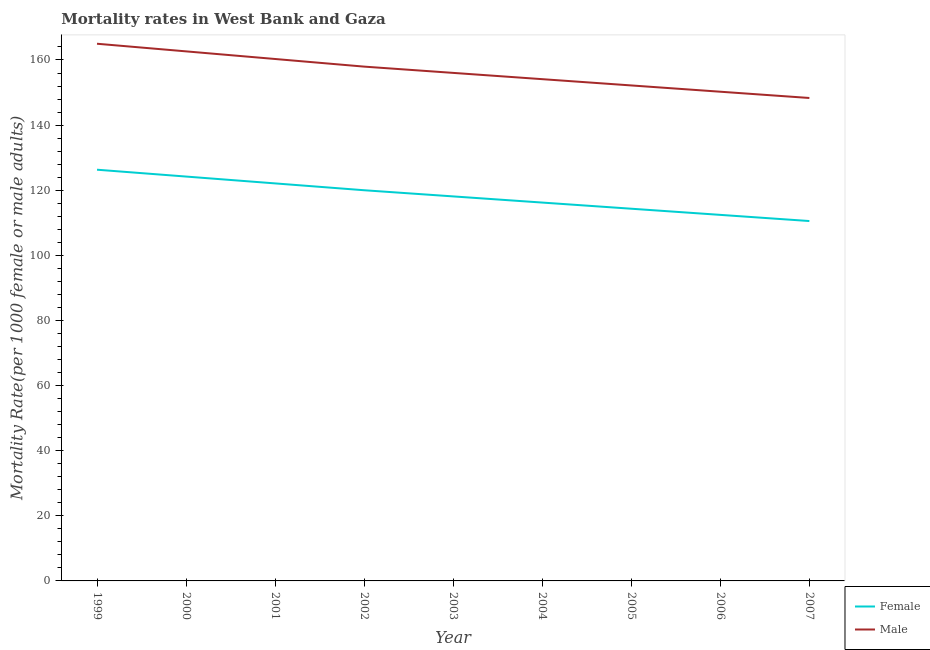Does the line corresponding to female mortality rate intersect with the line corresponding to male mortality rate?
Your response must be concise. No. What is the male mortality rate in 2000?
Your response must be concise. 162.65. Across all years, what is the maximum male mortality rate?
Your answer should be compact. 164.99. Across all years, what is the minimum male mortality rate?
Keep it short and to the point. 148.33. In which year was the male mortality rate maximum?
Offer a terse response. 1999. In which year was the male mortality rate minimum?
Offer a terse response. 2007. What is the total female mortality rate in the graph?
Ensure brevity in your answer.  1064.17. What is the difference between the male mortality rate in 2001 and that in 2005?
Ensure brevity in your answer.  8.12. What is the difference between the male mortality rate in 2004 and the female mortality rate in 2002?
Provide a succinct answer. 34.12. What is the average female mortality rate per year?
Make the answer very short. 118.24. In the year 2003, what is the difference between the female mortality rate and male mortality rate?
Your response must be concise. -37.94. In how many years, is the female mortality rate greater than 36?
Your answer should be very brief. 9. What is the ratio of the male mortality rate in 2000 to that in 2001?
Keep it short and to the point. 1.01. Is the female mortality rate in 2003 less than that in 2006?
Provide a short and direct response. No. What is the difference between the highest and the second highest male mortality rate?
Keep it short and to the point. 2.34. What is the difference between the highest and the lowest female mortality rate?
Offer a terse response. 15.76. In how many years, is the male mortality rate greater than the average male mortality rate taken over all years?
Provide a short and direct response. 4. Is the female mortality rate strictly less than the male mortality rate over the years?
Keep it short and to the point. Yes. How many lines are there?
Your response must be concise. 2. What is the difference between two consecutive major ticks on the Y-axis?
Make the answer very short. 20. Does the graph contain any zero values?
Make the answer very short. No. How are the legend labels stacked?
Your answer should be compact. Vertical. What is the title of the graph?
Give a very brief answer. Mortality rates in West Bank and Gaza. What is the label or title of the Y-axis?
Give a very brief answer. Mortality Rate(per 1000 female or male adults). What is the Mortality Rate(per 1000 female or male adults) in Female in 1999?
Provide a short and direct response. 126.3. What is the Mortality Rate(per 1000 female or male adults) of Male in 1999?
Your answer should be very brief. 164.99. What is the Mortality Rate(per 1000 female or male adults) in Female in 2000?
Give a very brief answer. 124.2. What is the Mortality Rate(per 1000 female or male adults) in Male in 2000?
Your response must be concise. 162.65. What is the Mortality Rate(per 1000 female or male adults) of Female in 2001?
Make the answer very short. 122.09. What is the Mortality Rate(per 1000 female or male adults) in Male in 2001?
Provide a short and direct response. 160.31. What is the Mortality Rate(per 1000 female or male adults) in Female in 2002?
Give a very brief answer. 119.99. What is the Mortality Rate(per 1000 female or male adults) of Male in 2002?
Your response must be concise. 157.96. What is the Mortality Rate(per 1000 female or male adults) in Female in 2003?
Your answer should be very brief. 118.1. What is the Mortality Rate(per 1000 female or male adults) of Male in 2003?
Your answer should be very brief. 156.04. What is the Mortality Rate(per 1000 female or male adults) in Female in 2004?
Ensure brevity in your answer.  116.21. What is the Mortality Rate(per 1000 female or male adults) in Male in 2004?
Offer a very short reply. 154.11. What is the Mortality Rate(per 1000 female or male adults) of Female in 2005?
Provide a short and direct response. 114.32. What is the Mortality Rate(per 1000 female or male adults) of Male in 2005?
Make the answer very short. 152.18. What is the Mortality Rate(per 1000 female or male adults) in Female in 2006?
Your response must be concise. 112.43. What is the Mortality Rate(per 1000 female or male adults) in Male in 2006?
Your response must be concise. 150.25. What is the Mortality Rate(per 1000 female or male adults) in Female in 2007?
Keep it short and to the point. 110.53. What is the Mortality Rate(per 1000 female or male adults) in Male in 2007?
Provide a short and direct response. 148.33. Across all years, what is the maximum Mortality Rate(per 1000 female or male adults) in Female?
Offer a very short reply. 126.3. Across all years, what is the maximum Mortality Rate(per 1000 female or male adults) of Male?
Ensure brevity in your answer.  164.99. Across all years, what is the minimum Mortality Rate(per 1000 female or male adults) of Female?
Offer a very short reply. 110.53. Across all years, what is the minimum Mortality Rate(per 1000 female or male adults) of Male?
Provide a short and direct response. 148.33. What is the total Mortality Rate(per 1000 female or male adults) of Female in the graph?
Offer a very short reply. 1064.17. What is the total Mortality Rate(per 1000 female or male adults) in Male in the graph?
Ensure brevity in your answer.  1406.81. What is the difference between the Mortality Rate(per 1000 female or male adults) in Female in 1999 and that in 2000?
Ensure brevity in your answer.  2.1. What is the difference between the Mortality Rate(per 1000 female or male adults) of Male in 1999 and that in 2000?
Give a very brief answer. 2.34. What is the difference between the Mortality Rate(per 1000 female or male adults) in Female in 1999 and that in 2001?
Give a very brief answer. 4.2. What is the difference between the Mortality Rate(per 1000 female or male adults) in Male in 1999 and that in 2001?
Make the answer very short. 4.68. What is the difference between the Mortality Rate(per 1000 female or male adults) in Female in 1999 and that in 2002?
Provide a short and direct response. 6.31. What is the difference between the Mortality Rate(per 1000 female or male adults) in Male in 1999 and that in 2002?
Offer a terse response. 7.03. What is the difference between the Mortality Rate(per 1000 female or male adults) in Female in 1999 and that in 2003?
Offer a very short reply. 8.2. What is the difference between the Mortality Rate(per 1000 female or male adults) in Male in 1999 and that in 2003?
Keep it short and to the point. 8.95. What is the difference between the Mortality Rate(per 1000 female or male adults) of Female in 1999 and that in 2004?
Give a very brief answer. 10.09. What is the difference between the Mortality Rate(per 1000 female or male adults) in Male in 1999 and that in 2004?
Give a very brief answer. 10.88. What is the difference between the Mortality Rate(per 1000 female or male adults) in Female in 1999 and that in 2005?
Offer a terse response. 11.98. What is the difference between the Mortality Rate(per 1000 female or male adults) of Male in 1999 and that in 2005?
Your answer should be very brief. 12.81. What is the difference between the Mortality Rate(per 1000 female or male adults) in Female in 1999 and that in 2006?
Ensure brevity in your answer.  13.87. What is the difference between the Mortality Rate(per 1000 female or male adults) in Male in 1999 and that in 2006?
Make the answer very short. 14.73. What is the difference between the Mortality Rate(per 1000 female or male adults) in Female in 1999 and that in 2007?
Provide a short and direct response. 15.76. What is the difference between the Mortality Rate(per 1000 female or male adults) of Male in 1999 and that in 2007?
Your answer should be compact. 16.66. What is the difference between the Mortality Rate(per 1000 female or male adults) in Female in 2000 and that in 2001?
Your answer should be very brief. 2.1. What is the difference between the Mortality Rate(per 1000 female or male adults) of Male in 2000 and that in 2001?
Provide a short and direct response. 2.34. What is the difference between the Mortality Rate(per 1000 female or male adults) of Female in 2000 and that in 2002?
Give a very brief answer. 4.2. What is the difference between the Mortality Rate(per 1000 female or male adults) in Male in 2000 and that in 2002?
Offer a very short reply. 4.68. What is the difference between the Mortality Rate(per 1000 female or male adults) in Female in 2000 and that in 2003?
Your answer should be very brief. 6.1. What is the difference between the Mortality Rate(per 1000 female or male adults) of Male in 2000 and that in 2003?
Your answer should be very brief. 6.61. What is the difference between the Mortality Rate(per 1000 female or male adults) of Female in 2000 and that in 2004?
Offer a terse response. 7.99. What is the difference between the Mortality Rate(per 1000 female or male adults) of Male in 2000 and that in 2004?
Offer a terse response. 8.54. What is the difference between the Mortality Rate(per 1000 female or male adults) in Female in 2000 and that in 2005?
Your answer should be very brief. 9.88. What is the difference between the Mortality Rate(per 1000 female or male adults) of Male in 2000 and that in 2005?
Give a very brief answer. 10.47. What is the difference between the Mortality Rate(per 1000 female or male adults) in Female in 2000 and that in 2006?
Your response must be concise. 11.77. What is the difference between the Mortality Rate(per 1000 female or male adults) in Male in 2000 and that in 2006?
Give a very brief answer. 12.39. What is the difference between the Mortality Rate(per 1000 female or male adults) in Female in 2000 and that in 2007?
Provide a short and direct response. 13.66. What is the difference between the Mortality Rate(per 1000 female or male adults) of Male in 2000 and that in 2007?
Make the answer very short. 14.32. What is the difference between the Mortality Rate(per 1000 female or male adults) in Female in 2001 and that in 2002?
Your response must be concise. 2.1. What is the difference between the Mortality Rate(per 1000 female or male adults) of Male in 2001 and that in 2002?
Provide a short and direct response. 2.34. What is the difference between the Mortality Rate(per 1000 female or male adults) of Female in 2001 and that in 2003?
Your response must be concise. 3.99. What is the difference between the Mortality Rate(per 1000 female or male adults) in Male in 2001 and that in 2003?
Your response must be concise. 4.27. What is the difference between the Mortality Rate(per 1000 female or male adults) of Female in 2001 and that in 2004?
Make the answer very short. 5.89. What is the difference between the Mortality Rate(per 1000 female or male adults) of Male in 2001 and that in 2004?
Keep it short and to the point. 6.2. What is the difference between the Mortality Rate(per 1000 female or male adults) of Female in 2001 and that in 2005?
Offer a terse response. 7.78. What is the difference between the Mortality Rate(per 1000 female or male adults) of Male in 2001 and that in 2005?
Your response must be concise. 8.12. What is the difference between the Mortality Rate(per 1000 female or male adults) of Female in 2001 and that in 2006?
Provide a succinct answer. 9.67. What is the difference between the Mortality Rate(per 1000 female or male adults) of Male in 2001 and that in 2006?
Your answer should be compact. 10.05. What is the difference between the Mortality Rate(per 1000 female or male adults) of Female in 2001 and that in 2007?
Give a very brief answer. 11.56. What is the difference between the Mortality Rate(per 1000 female or male adults) in Male in 2001 and that in 2007?
Give a very brief answer. 11.98. What is the difference between the Mortality Rate(per 1000 female or male adults) in Female in 2002 and that in 2003?
Offer a terse response. 1.89. What is the difference between the Mortality Rate(per 1000 female or male adults) of Male in 2002 and that in 2003?
Your response must be concise. 1.93. What is the difference between the Mortality Rate(per 1000 female or male adults) of Female in 2002 and that in 2004?
Your answer should be very brief. 3.78. What is the difference between the Mortality Rate(per 1000 female or male adults) of Male in 2002 and that in 2004?
Keep it short and to the point. 3.85. What is the difference between the Mortality Rate(per 1000 female or male adults) of Female in 2002 and that in 2005?
Provide a succinct answer. 5.67. What is the difference between the Mortality Rate(per 1000 female or male adults) in Male in 2002 and that in 2005?
Make the answer very short. 5.78. What is the difference between the Mortality Rate(per 1000 female or male adults) in Female in 2002 and that in 2006?
Offer a very short reply. 7.57. What is the difference between the Mortality Rate(per 1000 female or male adults) of Male in 2002 and that in 2006?
Your response must be concise. 7.71. What is the difference between the Mortality Rate(per 1000 female or male adults) in Female in 2002 and that in 2007?
Your response must be concise. 9.46. What is the difference between the Mortality Rate(per 1000 female or male adults) of Male in 2002 and that in 2007?
Ensure brevity in your answer.  9.64. What is the difference between the Mortality Rate(per 1000 female or male adults) in Female in 2003 and that in 2004?
Give a very brief answer. 1.89. What is the difference between the Mortality Rate(per 1000 female or male adults) in Male in 2003 and that in 2004?
Offer a terse response. 1.93. What is the difference between the Mortality Rate(per 1000 female or male adults) of Female in 2003 and that in 2005?
Provide a succinct answer. 3.78. What is the difference between the Mortality Rate(per 1000 female or male adults) of Male in 2003 and that in 2005?
Offer a terse response. 3.85. What is the difference between the Mortality Rate(per 1000 female or male adults) of Female in 2003 and that in 2006?
Offer a very short reply. 5.67. What is the difference between the Mortality Rate(per 1000 female or male adults) of Male in 2003 and that in 2006?
Make the answer very short. 5.78. What is the difference between the Mortality Rate(per 1000 female or male adults) in Female in 2003 and that in 2007?
Make the answer very short. 7.57. What is the difference between the Mortality Rate(per 1000 female or male adults) of Male in 2003 and that in 2007?
Your answer should be very brief. 7.71. What is the difference between the Mortality Rate(per 1000 female or male adults) in Female in 2004 and that in 2005?
Make the answer very short. 1.89. What is the difference between the Mortality Rate(per 1000 female or male adults) in Male in 2004 and that in 2005?
Your answer should be compact. 1.93. What is the difference between the Mortality Rate(per 1000 female or male adults) in Female in 2004 and that in 2006?
Offer a very short reply. 3.78. What is the difference between the Mortality Rate(per 1000 female or male adults) of Male in 2004 and that in 2006?
Make the answer very short. 3.85. What is the difference between the Mortality Rate(per 1000 female or male adults) of Female in 2004 and that in 2007?
Ensure brevity in your answer.  5.67. What is the difference between the Mortality Rate(per 1000 female or male adults) of Male in 2004 and that in 2007?
Ensure brevity in your answer.  5.78. What is the difference between the Mortality Rate(per 1000 female or male adults) in Female in 2005 and that in 2006?
Make the answer very short. 1.89. What is the difference between the Mortality Rate(per 1000 female or male adults) of Male in 2005 and that in 2006?
Your answer should be compact. 1.93. What is the difference between the Mortality Rate(per 1000 female or male adults) of Female in 2005 and that in 2007?
Make the answer very short. 3.78. What is the difference between the Mortality Rate(per 1000 female or male adults) in Male in 2005 and that in 2007?
Keep it short and to the point. 3.85. What is the difference between the Mortality Rate(per 1000 female or male adults) of Female in 2006 and that in 2007?
Your answer should be very brief. 1.89. What is the difference between the Mortality Rate(per 1000 female or male adults) in Male in 2006 and that in 2007?
Offer a very short reply. 1.93. What is the difference between the Mortality Rate(per 1000 female or male adults) of Female in 1999 and the Mortality Rate(per 1000 female or male adults) of Male in 2000?
Offer a terse response. -36.35. What is the difference between the Mortality Rate(per 1000 female or male adults) of Female in 1999 and the Mortality Rate(per 1000 female or male adults) of Male in 2001?
Your response must be concise. -34.01. What is the difference between the Mortality Rate(per 1000 female or male adults) of Female in 1999 and the Mortality Rate(per 1000 female or male adults) of Male in 2002?
Ensure brevity in your answer.  -31.66. What is the difference between the Mortality Rate(per 1000 female or male adults) in Female in 1999 and the Mortality Rate(per 1000 female or male adults) in Male in 2003?
Your answer should be very brief. -29.74. What is the difference between the Mortality Rate(per 1000 female or male adults) in Female in 1999 and the Mortality Rate(per 1000 female or male adults) in Male in 2004?
Provide a short and direct response. -27.81. What is the difference between the Mortality Rate(per 1000 female or male adults) of Female in 1999 and the Mortality Rate(per 1000 female or male adults) of Male in 2005?
Make the answer very short. -25.88. What is the difference between the Mortality Rate(per 1000 female or male adults) in Female in 1999 and the Mortality Rate(per 1000 female or male adults) in Male in 2006?
Offer a very short reply. -23.96. What is the difference between the Mortality Rate(per 1000 female or male adults) of Female in 1999 and the Mortality Rate(per 1000 female or male adults) of Male in 2007?
Ensure brevity in your answer.  -22.03. What is the difference between the Mortality Rate(per 1000 female or male adults) in Female in 2000 and the Mortality Rate(per 1000 female or male adults) in Male in 2001?
Make the answer very short. -36.11. What is the difference between the Mortality Rate(per 1000 female or male adults) of Female in 2000 and the Mortality Rate(per 1000 female or male adults) of Male in 2002?
Provide a succinct answer. -33.77. What is the difference between the Mortality Rate(per 1000 female or male adults) in Female in 2000 and the Mortality Rate(per 1000 female or male adults) in Male in 2003?
Your answer should be very brief. -31.84. What is the difference between the Mortality Rate(per 1000 female or male adults) in Female in 2000 and the Mortality Rate(per 1000 female or male adults) in Male in 2004?
Your response must be concise. -29.91. What is the difference between the Mortality Rate(per 1000 female or male adults) in Female in 2000 and the Mortality Rate(per 1000 female or male adults) in Male in 2005?
Your response must be concise. -27.99. What is the difference between the Mortality Rate(per 1000 female or male adults) in Female in 2000 and the Mortality Rate(per 1000 female or male adults) in Male in 2006?
Keep it short and to the point. -26.06. What is the difference between the Mortality Rate(per 1000 female or male adults) in Female in 2000 and the Mortality Rate(per 1000 female or male adults) in Male in 2007?
Your response must be concise. -24.13. What is the difference between the Mortality Rate(per 1000 female or male adults) of Female in 2001 and the Mortality Rate(per 1000 female or male adults) of Male in 2002?
Keep it short and to the point. -35.87. What is the difference between the Mortality Rate(per 1000 female or male adults) of Female in 2001 and the Mortality Rate(per 1000 female or male adults) of Male in 2003?
Your response must be concise. -33.94. What is the difference between the Mortality Rate(per 1000 female or male adults) in Female in 2001 and the Mortality Rate(per 1000 female or male adults) in Male in 2004?
Provide a short and direct response. -32.01. What is the difference between the Mortality Rate(per 1000 female or male adults) of Female in 2001 and the Mortality Rate(per 1000 female or male adults) of Male in 2005?
Your answer should be very brief. -30.09. What is the difference between the Mortality Rate(per 1000 female or male adults) of Female in 2001 and the Mortality Rate(per 1000 female or male adults) of Male in 2006?
Your answer should be very brief. -28.16. What is the difference between the Mortality Rate(per 1000 female or male adults) of Female in 2001 and the Mortality Rate(per 1000 female or male adults) of Male in 2007?
Your answer should be compact. -26.23. What is the difference between the Mortality Rate(per 1000 female or male adults) of Female in 2002 and the Mortality Rate(per 1000 female or male adults) of Male in 2003?
Offer a terse response. -36.04. What is the difference between the Mortality Rate(per 1000 female or male adults) of Female in 2002 and the Mortality Rate(per 1000 female or male adults) of Male in 2004?
Your answer should be compact. -34.12. What is the difference between the Mortality Rate(per 1000 female or male adults) in Female in 2002 and the Mortality Rate(per 1000 female or male adults) in Male in 2005?
Your response must be concise. -32.19. What is the difference between the Mortality Rate(per 1000 female or male adults) in Female in 2002 and the Mortality Rate(per 1000 female or male adults) in Male in 2006?
Your answer should be compact. -30.26. What is the difference between the Mortality Rate(per 1000 female or male adults) in Female in 2002 and the Mortality Rate(per 1000 female or male adults) in Male in 2007?
Offer a terse response. -28.34. What is the difference between the Mortality Rate(per 1000 female or male adults) in Female in 2003 and the Mortality Rate(per 1000 female or male adults) in Male in 2004?
Keep it short and to the point. -36.01. What is the difference between the Mortality Rate(per 1000 female or male adults) in Female in 2003 and the Mortality Rate(per 1000 female or male adults) in Male in 2005?
Provide a short and direct response. -34.08. What is the difference between the Mortality Rate(per 1000 female or male adults) of Female in 2003 and the Mortality Rate(per 1000 female or male adults) of Male in 2006?
Give a very brief answer. -32.15. What is the difference between the Mortality Rate(per 1000 female or male adults) in Female in 2003 and the Mortality Rate(per 1000 female or male adults) in Male in 2007?
Keep it short and to the point. -30.23. What is the difference between the Mortality Rate(per 1000 female or male adults) of Female in 2004 and the Mortality Rate(per 1000 female or male adults) of Male in 2005?
Your answer should be compact. -35.97. What is the difference between the Mortality Rate(per 1000 female or male adults) in Female in 2004 and the Mortality Rate(per 1000 female or male adults) in Male in 2006?
Provide a succinct answer. -34.05. What is the difference between the Mortality Rate(per 1000 female or male adults) of Female in 2004 and the Mortality Rate(per 1000 female or male adults) of Male in 2007?
Offer a terse response. -32.12. What is the difference between the Mortality Rate(per 1000 female or male adults) in Female in 2005 and the Mortality Rate(per 1000 female or male adults) in Male in 2006?
Offer a very short reply. -35.94. What is the difference between the Mortality Rate(per 1000 female or male adults) of Female in 2005 and the Mortality Rate(per 1000 female or male adults) of Male in 2007?
Your answer should be very brief. -34.01. What is the difference between the Mortality Rate(per 1000 female or male adults) in Female in 2006 and the Mortality Rate(per 1000 female or male adults) in Male in 2007?
Offer a very short reply. -35.9. What is the average Mortality Rate(per 1000 female or male adults) in Female per year?
Provide a succinct answer. 118.24. What is the average Mortality Rate(per 1000 female or male adults) of Male per year?
Provide a short and direct response. 156.31. In the year 1999, what is the difference between the Mortality Rate(per 1000 female or male adults) in Female and Mortality Rate(per 1000 female or male adults) in Male?
Provide a succinct answer. -38.69. In the year 2000, what is the difference between the Mortality Rate(per 1000 female or male adults) of Female and Mortality Rate(per 1000 female or male adults) of Male?
Your answer should be compact. -38.45. In the year 2001, what is the difference between the Mortality Rate(per 1000 female or male adults) of Female and Mortality Rate(per 1000 female or male adults) of Male?
Your response must be concise. -38.21. In the year 2002, what is the difference between the Mortality Rate(per 1000 female or male adults) of Female and Mortality Rate(per 1000 female or male adults) of Male?
Your answer should be very brief. -37.97. In the year 2003, what is the difference between the Mortality Rate(per 1000 female or male adults) in Female and Mortality Rate(per 1000 female or male adults) in Male?
Provide a short and direct response. -37.94. In the year 2004, what is the difference between the Mortality Rate(per 1000 female or male adults) in Female and Mortality Rate(per 1000 female or male adults) in Male?
Give a very brief answer. -37.9. In the year 2005, what is the difference between the Mortality Rate(per 1000 female or male adults) in Female and Mortality Rate(per 1000 female or male adults) in Male?
Provide a short and direct response. -37.86. In the year 2006, what is the difference between the Mortality Rate(per 1000 female or male adults) of Female and Mortality Rate(per 1000 female or male adults) of Male?
Your response must be concise. -37.83. In the year 2007, what is the difference between the Mortality Rate(per 1000 female or male adults) in Female and Mortality Rate(per 1000 female or male adults) in Male?
Offer a very short reply. -37.79. What is the ratio of the Mortality Rate(per 1000 female or male adults) of Female in 1999 to that in 2000?
Your answer should be compact. 1.02. What is the ratio of the Mortality Rate(per 1000 female or male adults) in Male in 1999 to that in 2000?
Offer a very short reply. 1.01. What is the ratio of the Mortality Rate(per 1000 female or male adults) of Female in 1999 to that in 2001?
Ensure brevity in your answer.  1.03. What is the ratio of the Mortality Rate(per 1000 female or male adults) in Male in 1999 to that in 2001?
Make the answer very short. 1.03. What is the ratio of the Mortality Rate(per 1000 female or male adults) of Female in 1999 to that in 2002?
Your answer should be compact. 1.05. What is the ratio of the Mortality Rate(per 1000 female or male adults) in Male in 1999 to that in 2002?
Your response must be concise. 1.04. What is the ratio of the Mortality Rate(per 1000 female or male adults) of Female in 1999 to that in 2003?
Make the answer very short. 1.07. What is the ratio of the Mortality Rate(per 1000 female or male adults) in Male in 1999 to that in 2003?
Offer a very short reply. 1.06. What is the ratio of the Mortality Rate(per 1000 female or male adults) in Female in 1999 to that in 2004?
Give a very brief answer. 1.09. What is the ratio of the Mortality Rate(per 1000 female or male adults) of Male in 1999 to that in 2004?
Offer a terse response. 1.07. What is the ratio of the Mortality Rate(per 1000 female or male adults) in Female in 1999 to that in 2005?
Keep it short and to the point. 1.1. What is the ratio of the Mortality Rate(per 1000 female or male adults) in Male in 1999 to that in 2005?
Ensure brevity in your answer.  1.08. What is the ratio of the Mortality Rate(per 1000 female or male adults) of Female in 1999 to that in 2006?
Make the answer very short. 1.12. What is the ratio of the Mortality Rate(per 1000 female or male adults) of Male in 1999 to that in 2006?
Your answer should be very brief. 1.1. What is the ratio of the Mortality Rate(per 1000 female or male adults) in Female in 1999 to that in 2007?
Offer a terse response. 1.14. What is the ratio of the Mortality Rate(per 1000 female or male adults) of Male in 1999 to that in 2007?
Your answer should be compact. 1.11. What is the ratio of the Mortality Rate(per 1000 female or male adults) of Female in 2000 to that in 2001?
Offer a very short reply. 1.02. What is the ratio of the Mortality Rate(per 1000 female or male adults) of Male in 2000 to that in 2001?
Offer a terse response. 1.01. What is the ratio of the Mortality Rate(per 1000 female or male adults) in Female in 2000 to that in 2002?
Give a very brief answer. 1.03. What is the ratio of the Mortality Rate(per 1000 female or male adults) of Male in 2000 to that in 2002?
Your answer should be compact. 1.03. What is the ratio of the Mortality Rate(per 1000 female or male adults) in Female in 2000 to that in 2003?
Make the answer very short. 1.05. What is the ratio of the Mortality Rate(per 1000 female or male adults) in Male in 2000 to that in 2003?
Offer a terse response. 1.04. What is the ratio of the Mortality Rate(per 1000 female or male adults) in Female in 2000 to that in 2004?
Provide a succinct answer. 1.07. What is the ratio of the Mortality Rate(per 1000 female or male adults) in Male in 2000 to that in 2004?
Make the answer very short. 1.06. What is the ratio of the Mortality Rate(per 1000 female or male adults) in Female in 2000 to that in 2005?
Make the answer very short. 1.09. What is the ratio of the Mortality Rate(per 1000 female or male adults) in Male in 2000 to that in 2005?
Your answer should be very brief. 1.07. What is the ratio of the Mortality Rate(per 1000 female or male adults) of Female in 2000 to that in 2006?
Your answer should be very brief. 1.1. What is the ratio of the Mortality Rate(per 1000 female or male adults) of Male in 2000 to that in 2006?
Provide a short and direct response. 1.08. What is the ratio of the Mortality Rate(per 1000 female or male adults) in Female in 2000 to that in 2007?
Offer a very short reply. 1.12. What is the ratio of the Mortality Rate(per 1000 female or male adults) in Male in 2000 to that in 2007?
Your answer should be very brief. 1.1. What is the ratio of the Mortality Rate(per 1000 female or male adults) of Female in 2001 to that in 2002?
Your response must be concise. 1.02. What is the ratio of the Mortality Rate(per 1000 female or male adults) in Male in 2001 to that in 2002?
Your answer should be very brief. 1.01. What is the ratio of the Mortality Rate(per 1000 female or male adults) in Female in 2001 to that in 2003?
Your answer should be compact. 1.03. What is the ratio of the Mortality Rate(per 1000 female or male adults) of Male in 2001 to that in 2003?
Keep it short and to the point. 1.03. What is the ratio of the Mortality Rate(per 1000 female or male adults) of Female in 2001 to that in 2004?
Your response must be concise. 1.05. What is the ratio of the Mortality Rate(per 1000 female or male adults) of Male in 2001 to that in 2004?
Provide a short and direct response. 1.04. What is the ratio of the Mortality Rate(per 1000 female or male adults) of Female in 2001 to that in 2005?
Give a very brief answer. 1.07. What is the ratio of the Mortality Rate(per 1000 female or male adults) in Male in 2001 to that in 2005?
Your answer should be very brief. 1.05. What is the ratio of the Mortality Rate(per 1000 female or male adults) of Female in 2001 to that in 2006?
Provide a short and direct response. 1.09. What is the ratio of the Mortality Rate(per 1000 female or male adults) in Male in 2001 to that in 2006?
Make the answer very short. 1.07. What is the ratio of the Mortality Rate(per 1000 female or male adults) in Female in 2001 to that in 2007?
Keep it short and to the point. 1.1. What is the ratio of the Mortality Rate(per 1000 female or male adults) of Male in 2001 to that in 2007?
Your response must be concise. 1.08. What is the ratio of the Mortality Rate(per 1000 female or male adults) in Female in 2002 to that in 2003?
Offer a very short reply. 1.02. What is the ratio of the Mortality Rate(per 1000 female or male adults) in Male in 2002 to that in 2003?
Your answer should be compact. 1.01. What is the ratio of the Mortality Rate(per 1000 female or male adults) of Female in 2002 to that in 2004?
Offer a terse response. 1.03. What is the ratio of the Mortality Rate(per 1000 female or male adults) of Female in 2002 to that in 2005?
Offer a terse response. 1.05. What is the ratio of the Mortality Rate(per 1000 female or male adults) in Male in 2002 to that in 2005?
Ensure brevity in your answer.  1.04. What is the ratio of the Mortality Rate(per 1000 female or male adults) in Female in 2002 to that in 2006?
Your response must be concise. 1.07. What is the ratio of the Mortality Rate(per 1000 female or male adults) in Male in 2002 to that in 2006?
Keep it short and to the point. 1.05. What is the ratio of the Mortality Rate(per 1000 female or male adults) in Female in 2002 to that in 2007?
Provide a succinct answer. 1.09. What is the ratio of the Mortality Rate(per 1000 female or male adults) in Male in 2002 to that in 2007?
Give a very brief answer. 1.06. What is the ratio of the Mortality Rate(per 1000 female or male adults) of Female in 2003 to that in 2004?
Ensure brevity in your answer.  1.02. What is the ratio of the Mortality Rate(per 1000 female or male adults) in Male in 2003 to that in 2004?
Ensure brevity in your answer.  1.01. What is the ratio of the Mortality Rate(per 1000 female or male adults) of Female in 2003 to that in 2005?
Make the answer very short. 1.03. What is the ratio of the Mortality Rate(per 1000 female or male adults) in Male in 2003 to that in 2005?
Ensure brevity in your answer.  1.03. What is the ratio of the Mortality Rate(per 1000 female or male adults) of Female in 2003 to that in 2006?
Your answer should be compact. 1.05. What is the ratio of the Mortality Rate(per 1000 female or male adults) in Female in 2003 to that in 2007?
Offer a terse response. 1.07. What is the ratio of the Mortality Rate(per 1000 female or male adults) in Male in 2003 to that in 2007?
Offer a terse response. 1.05. What is the ratio of the Mortality Rate(per 1000 female or male adults) of Female in 2004 to that in 2005?
Your answer should be very brief. 1.02. What is the ratio of the Mortality Rate(per 1000 female or male adults) of Male in 2004 to that in 2005?
Keep it short and to the point. 1.01. What is the ratio of the Mortality Rate(per 1000 female or male adults) of Female in 2004 to that in 2006?
Make the answer very short. 1.03. What is the ratio of the Mortality Rate(per 1000 female or male adults) of Male in 2004 to that in 2006?
Your answer should be very brief. 1.03. What is the ratio of the Mortality Rate(per 1000 female or male adults) of Female in 2004 to that in 2007?
Your answer should be compact. 1.05. What is the ratio of the Mortality Rate(per 1000 female or male adults) of Male in 2004 to that in 2007?
Your answer should be compact. 1.04. What is the ratio of the Mortality Rate(per 1000 female or male adults) in Female in 2005 to that in 2006?
Keep it short and to the point. 1.02. What is the ratio of the Mortality Rate(per 1000 female or male adults) in Male in 2005 to that in 2006?
Give a very brief answer. 1.01. What is the ratio of the Mortality Rate(per 1000 female or male adults) in Female in 2005 to that in 2007?
Your answer should be compact. 1.03. What is the ratio of the Mortality Rate(per 1000 female or male adults) of Female in 2006 to that in 2007?
Ensure brevity in your answer.  1.02. What is the difference between the highest and the second highest Mortality Rate(per 1000 female or male adults) of Female?
Your answer should be very brief. 2.1. What is the difference between the highest and the second highest Mortality Rate(per 1000 female or male adults) of Male?
Your answer should be compact. 2.34. What is the difference between the highest and the lowest Mortality Rate(per 1000 female or male adults) of Female?
Offer a very short reply. 15.76. What is the difference between the highest and the lowest Mortality Rate(per 1000 female or male adults) of Male?
Your answer should be compact. 16.66. 